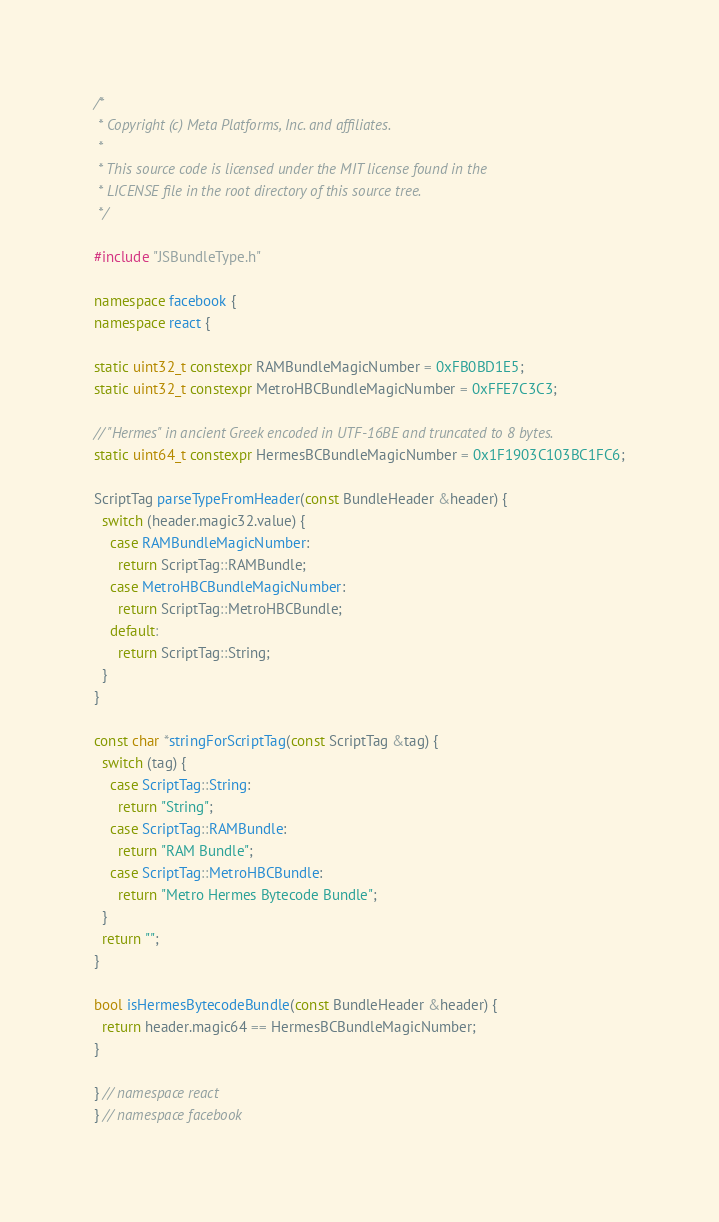<code> <loc_0><loc_0><loc_500><loc_500><_C++_>/*
 * Copyright (c) Meta Platforms, Inc. and affiliates.
 *
 * This source code is licensed under the MIT license found in the
 * LICENSE file in the root directory of this source tree.
 */

#include "JSBundleType.h"

namespace facebook {
namespace react {

static uint32_t constexpr RAMBundleMagicNumber = 0xFB0BD1E5;
static uint32_t constexpr MetroHBCBundleMagicNumber = 0xFFE7C3C3;

// "Hermes" in ancient Greek encoded in UTF-16BE and truncated to 8 bytes.
static uint64_t constexpr HermesBCBundleMagicNumber = 0x1F1903C103BC1FC6;

ScriptTag parseTypeFromHeader(const BundleHeader &header) {
  switch (header.magic32.value) {
    case RAMBundleMagicNumber:
      return ScriptTag::RAMBundle;
    case MetroHBCBundleMagicNumber:
      return ScriptTag::MetroHBCBundle;
    default:
      return ScriptTag::String;
  }
}

const char *stringForScriptTag(const ScriptTag &tag) {
  switch (tag) {
    case ScriptTag::String:
      return "String";
    case ScriptTag::RAMBundle:
      return "RAM Bundle";
    case ScriptTag::MetroHBCBundle:
      return "Metro Hermes Bytecode Bundle";
  }
  return "";
}

bool isHermesBytecodeBundle(const BundleHeader &header) {
  return header.magic64 == HermesBCBundleMagicNumber;
}

} // namespace react
} // namespace facebook
</code> 